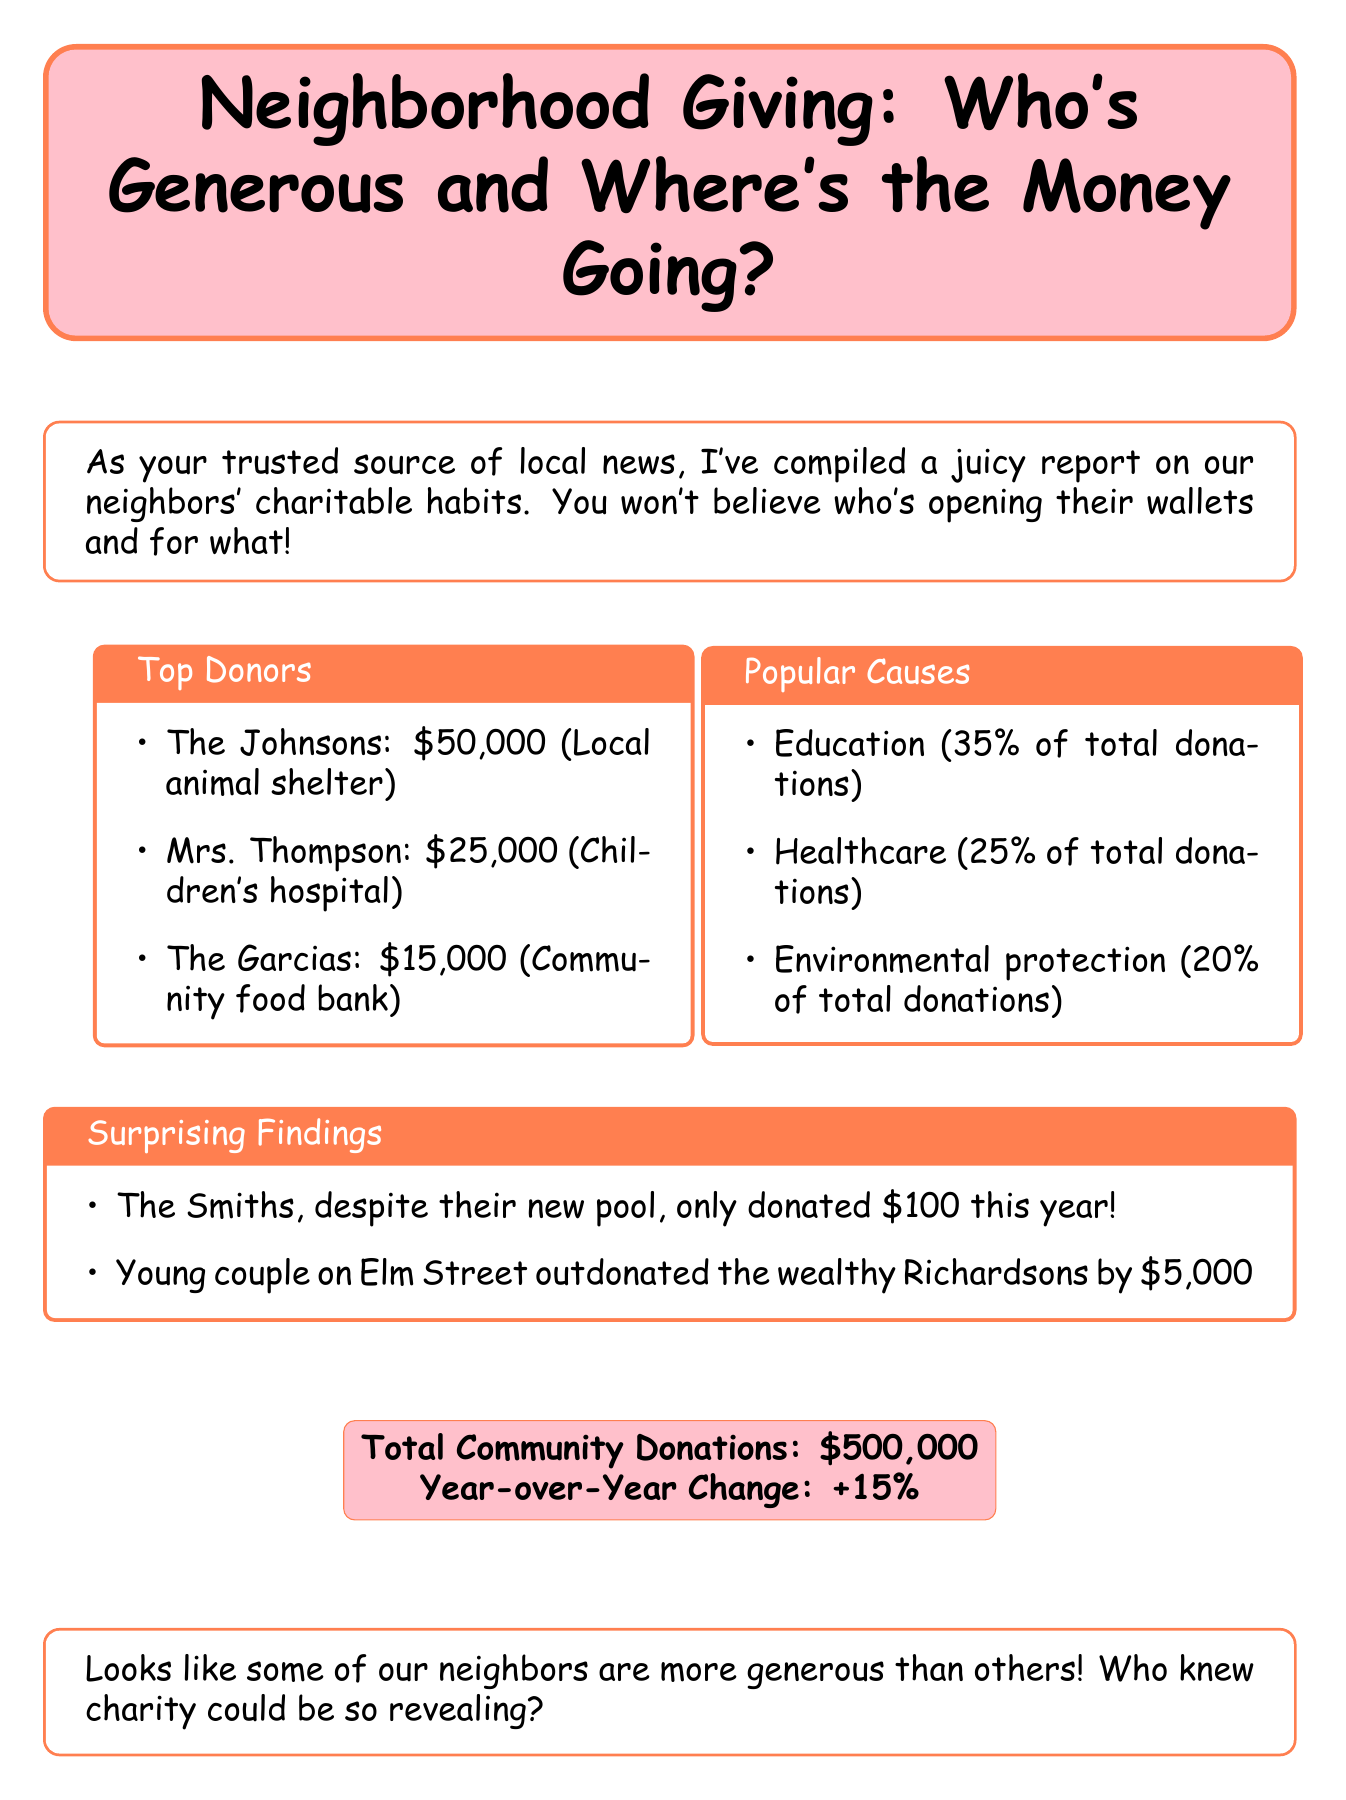What is the title of the report? The title is stated at the beginning of the document, highlighting the main topic about charitable donations in the neighborhood.
Answer: Neighborhood Giving: Who's Generous and Where's the Money Going? Who donated the most? The document lists the top donors with the amount they donated, showcasing the highest contributor.
Answer: The Johnsons How much did Mrs. Thompson donate? The donation amounts for individual donors are presented in the top donors section, specifically for Mrs. Thompson.
Answer: $25,000 What percentage of donations went to education? The popular causes section outlines the distribution of donations by percentage, specifically for education.
Answer: 35% What is the total amount of community donations? The total donations collected by the community is summarized in the document, providing a clear financial overview.
Answer: $500,000 What was the year-over-year change in donations? The document includes a comparison of donations from the previous year, indicating growth or decline.
Answer: +15% Which cause received the least donations based on the popular causes? Analyzing the popular causes helps identify which area received the least support via percentage.
Answer: Environmental protection What surprising finding was noted about the Smiths' donations? The document offers unexpected insights into donor behavior, specifically regarding the Smiths' contributions.
Answer: Only donated $100 Which couple outdonated the Richardsons? The surprising findings section mentions a couple who surpassed the Richardsons in their donations.
Answer: Young couple on Elm Street 